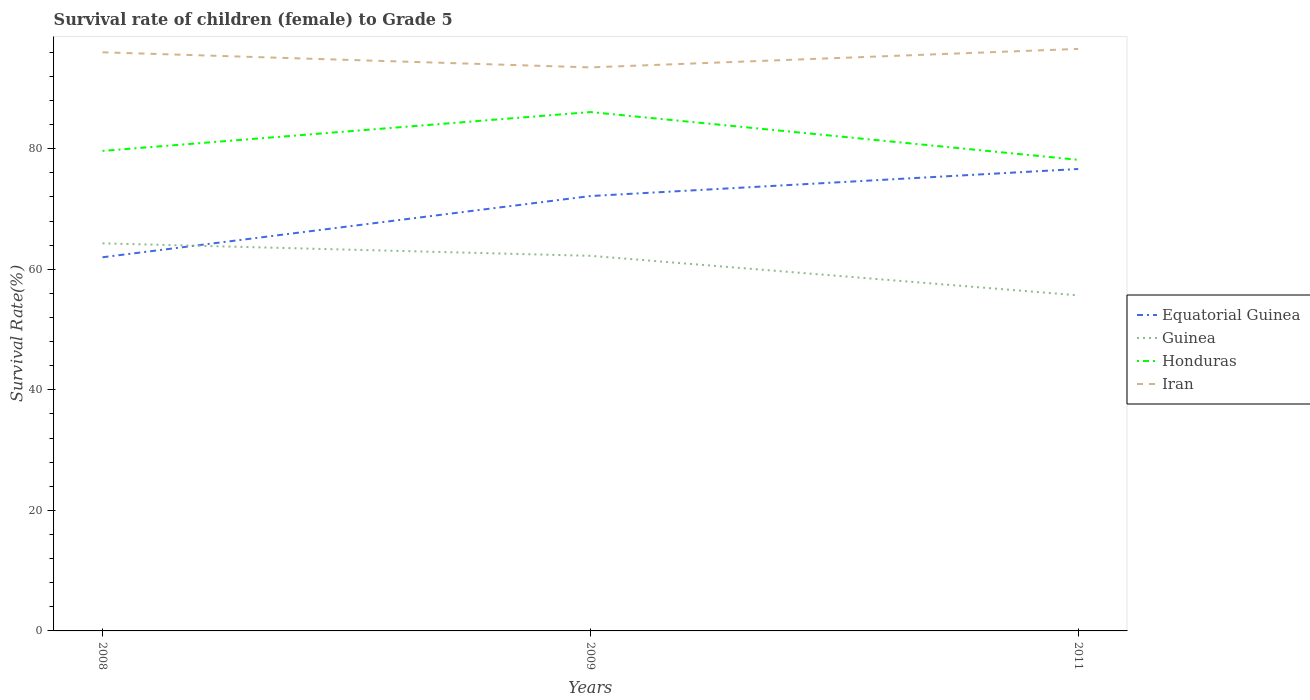Does the line corresponding to Iran intersect with the line corresponding to Honduras?
Ensure brevity in your answer.  No. Is the number of lines equal to the number of legend labels?
Your answer should be very brief. Yes. Across all years, what is the maximum survival rate of female children to grade 5 in Iran?
Offer a terse response. 93.49. What is the total survival rate of female children to grade 5 in Iran in the graph?
Your response must be concise. 2.5. What is the difference between the highest and the second highest survival rate of female children to grade 5 in Iran?
Offer a terse response. 3.07. What is the difference between the highest and the lowest survival rate of female children to grade 5 in Guinea?
Provide a succinct answer. 2. Is the survival rate of female children to grade 5 in Honduras strictly greater than the survival rate of female children to grade 5 in Equatorial Guinea over the years?
Your answer should be compact. No. How many lines are there?
Your answer should be very brief. 4. Does the graph contain grids?
Give a very brief answer. No. Where does the legend appear in the graph?
Offer a very short reply. Center right. What is the title of the graph?
Keep it short and to the point. Survival rate of children (female) to Grade 5. Does "Ireland" appear as one of the legend labels in the graph?
Your answer should be very brief. No. What is the label or title of the X-axis?
Your answer should be compact. Years. What is the label or title of the Y-axis?
Offer a very short reply. Survival Rate(%). What is the Survival Rate(%) in Equatorial Guinea in 2008?
Your response must be concise. 61.99. What is the Survival Rate(%) of Guinea in 2008?
Offer a terse response. 64.3. What is the Survival Rate(%) of Honduras in 2008?
Keep it short and to the point. 79.63. What is the Survival Rate(%) of Iran in 2008?
Give a very brief answer. 95.99. What is the Survival Rate(%) of Equatorial Guinea in 2009?
Make the answer very short. 72.14. What is the Survival Rate(%) in Guinea in 2009?
Provide a short and direct response. 62.23. What is the Survival Rate(%) of Honduras in 2009?
Provide a short and direct response. 86.08. What is the Survival Rate(%) of Iran in 2009?
Offer a terse response. 93.49. What is the Survival Rate(%) of Equatorial Guinea in 2011?
Offer a very short reply. 76.63. What is the Survival Rate(%) in Guinea in 2011?
Your answer should be very brief. 55.67. What is the Survival Rate(%) of Honduras in 2011?
Your response must be concise. 78.15. What is the Survival Rate(%) in Iran in 2011?
Make the answer very short. 96.55. Across all years, what is the maximum Survival Rate(%) in Equatorial Guinea?
Give a very brief answer. 76.63. Across all years, what is the maximum Survival Rate(%) in Guinea?
Ensure brevity in your answer.  64.3. Across all years, what is the maximum Survival Rate(%) of Honduras?
Your answer should be very brief. 86.08. Across all years, what is the maximum Survival Rate(%) of Iran?
Give a very brief answer. 96.55. Across all years, what is the minimum Survival Rate(%) of Equatorial Guinea?
Keep it short and to the point. 61.99. Across all years, what is the minimum Survival Rate(%) of Guinea?
Your answer should be very brief. 55.67. Across all years, what is the minimum Survival Rate(%) in Honduras?
Offer a terse response. 78.15. Across all years, what is the minimum Survival Rate(%) in Iran?
Provide a succinct answer. 93.49. What is the total Survival Rate(%) in Equatorial Guinea in the graph?
Offer a terse response. 210.76. What is the total Survival Rate(%) of Guinea in the graph?
Your answer should be compact. 182.2. What is the total Survival Rate(%) in Honduras in the graph?
Keep it short and to the point. 243.86. What is the total Survival Rate(%) in Iran in the graph?
Provide a short and direct response. 286.03. What is the difference between the Survival Rate(%) of Equatorial Guinea in 2008 and that in 2009?
Provide a short and direct response. -10.16. What is the difference between the Survival Rate(%) in Guinea in 2008 and that in 2009?
Your response must be concise. 2.07. What is the difference between the Survival Rate(%) in Honduras in 2008 and that in 2009?
Provide a succinct answer. -6.44. What is the difference between the Survival Rate(%) of Iran in 2008 and that in 2009?
Your response must be concise. 2.5. What is the difference between the Survival Rate(%) in Equatorial Guinea in 2008 and that in 2011?
Ensure brevity in your answer.  -14.65. What is the difference between the Survival Rate(%) of Guinea in 2008 and that in 2011?
Ensure brevity in your answer.  8.62. What is the difference between the Survival Rate(%) of Honduras in 2008 and that in 2011?
Offer a terse response. 1.48. What is the difference between the Survival Rate(%) of Iran in 2008 and that in 2011?
Offer a terse response. -0.56. What is the difference between the Survival Rate(%) in Equatorial Guinea in 2009 and that in 2011?
Ensure brevity in your answer.  -4.49. What is the difference between the Survival Rate(%) of Guinea in 2009 and that in 2011?
Your answer should be very brief. 6.56. What is the difference between the Survival Rate(%) of Honduras in 2009 and that in 2011?
Give a very brief answer. 7.93. What is the difference between the Survival Rate(%) in Iran in 2009 and that in 2011?
Offer a terse response. -3.07. What is the difference between the Survival Rate(%) in Equatorial Guinea in 2008 and the Survival Rate(%) in Guinea in 2009?
Your response must be concise. -0.24. What is the difference between the Survival Rate(%) of Equatorial Guinea in 2008 and the Survival Rate(%) of Honduras in 2009?
Make the answer very short. -24.09. What is the difference between the Survival Rate(%) in Equatorial Guinea in 2008 and the Survival Rate(%) in Iran in 2009?
Offer a very short reply. -31.5. What is the difference between the Survival Rate(%) in Guinea in 2008 and the Survival Rate(%) in Honduras in 2009?
Your answer should be very brief. -21.78. What is the difference between the Survival Rate(%) of Guinea in 2008 and the Survival Rate(%) of Iran in 2009?
Offer a very short reply. -29.19. What is the difference between the Survival Rate(%) of Honduras in 2008 and the Survival Rate(%) of Iran in 2009?
Make the answer very short. -13.85. What is the difference between the Survival Rate(%) of Equatorial Guinea in 2008 and the Survival Rate(%) of Guinea in 2011?
Keep it short and to the point. 6.31. What is the difference between the Survival Rate(%) of Equatorial Guinea in 2008 and the Survival Rate(%) of Honduras in 2011?
Give a very brief answer. -16.16. What is the difference between the Survival Rate(%) in Equatorial Guinea in 2008 and the Survival Rate(%) in Iran in 2011?
Keep it short and to the point. -34.57. What is the difference between the Survival Rate(%) of Guinea in 2008 and the Survival Rate(%) of Honduras in 2011?
Offer a very short reply. -13.85. What is the difference between the Survival Rate(%) of Guinea in 2008 and the Survival Rate(%) of Iran in 2011?
Provide a succinct answer. -32.26. What is the difference between the Survival Rate(%) in Honduras in 2008 and the Survival Rate(%) in Iran in 2011?
Make the answer very short. -16.92. What is the difference between the Survival Rate(%) of Equatorial Guinea in 2009 and the Survival Rate(%) of Guinea in 2011?
Give a very brief answer. 16.47. What is the difference between the Survival Rate(%) of Equatorial Guinea in 2009 and the Survival Rate(%) of Honduras in 2011?
Give a very brief answer. -6.01. What is the difference between the Survival Rate(%) in Equatorial Guinea in 2009 and the Survival Rate(%) in Iran in 2011?
Your answer should be compact. -24.41. What is the difference between the Survival Rate(%) in Guinea in 2009 and the Survival Rate(%) in Honduras in 2011?
Make the answer very short. -15.92. What is the difference between the Survival Rate(%) in Guinea in 2009 and the Survival Rate(%) in Iran in 2011?
Offer a terse response. -34.32. What is the difference between the Survival Rate(%) in Honduras in 2009 and the Survival Rate(%) in Iran in 2011?
Offer a very short reply. -10.48. What is the average Survival Rate(%) of Equatorial Guinea per year?
Your response must be concise. 70.25. What is the average Survival Rate(%) of Guinea per year?
Give a very brief answer. 60.73. What is the average Survival Rate(%) in Honduras per year?
Give a very brief answer. 81.29. What is the average Survival Rate(%) in Iran per year?
Offer a terse response. 95.34. In the year 2008, what is the difference between the Survival Rate(%) in Equatorial Guinea and Survival Rate(%) in Guinea?
Your answer should be very brief. -2.31. In the year 2008, what is the difference between the Survival Rate(%) in Equatorial Guinea and Survival Rate(%) in Honduras?
Your response must be concise. -17.65. In the year 2008, what is the difference between the Survival Rate(%) of Equatorial Guinea and Survival Rate(%) of Iran?
Your response must be concise. -34. In the year 2008, what is the difference between the Survival Rate(%) in Guinea and Survival Rate(%) in Honduras?
Ensure brevity in your answer.  -15.34. In the year 2008, what is the difference between the Survival Rate(%) in Guinea and Survival Rate(%) in Iran?
Your answer should be compact. -31.69. In the year 2008, what is the difference between the Survival Rate(%) in Honduras and Survival Rate(%) in Iran?
Give a very brief answer. -16.36. In the year 2009, what is the difference between the Survival Rate(%) of Equatorial Guinea and Survival Rate(%) of Guinea?
Your answer should be very brief. 9.91. In the year 2009, what is the difference between the Survival Rate(%) of Equatorial Guinea and Survival Rate(%) of Honduras?
Give a very brief answer. -13.93. In the year 2009, what is the difference between the Survival Rate(%) in Equatorial Guinea and Survival Rate(%) in Iran?
Keep it short and to the point. -21.34. In the year 2009, what is the difference between the Survival Rate(%) in Guinea and Survival Rate(%) in Honduras?
Give a very brief answer. -23.85. In the year 2009, what is the difference between the Survival Rate(%) in Guinea and Survival Rate(%) in Iran?
Your answer should be very brief. -31.26. In the year 2009, what is the difference between the Survival Rate(%) of Honduras and Survival Rate(%) of Iran?
Your answer should be compact. -7.41. In the year 2011, what is the difference between the Survival Rate(%) of Equatorial Guinea and Survival Rate(%) of Guinea?
Make the answer very short. 20.96. In the year 2011, what is the difference between the Survival Rate(%) of Equatorial Guinea and Survival Rate(%) of Honduras?
Make the answer very short. -1.52. In the year 2011, what is the difference between the Survival Rate(%) in Equatorial Guinea and Survival Rate(%) in Iran?
Offer a very short reply. -19.92. In the year 2011, what is the difference between the Survival Rate(%) in Guinea and Survival Rate(%) in Honduras?
Offer a terse response. -22.48. In the year 2011, what is the difference between the Survival Rate(%) of Guinea and Survival Rate(%) of Iran?
Give a very brief answer. -40.88. In the year 2011, what is the difference between the Survival Rate(%) in Honduras and Survival Rate(%) in Iran?
Offer a terse response. -18.4. What is the ratio of the Survival Rate(%) of Equatorial Guinea in 2008 to that in 2009?
Give a very brief answer. 0.86. What is the ratio of the Survival Rate(%) of Guinea in 2008 to that in 2009?
Keep it short and to the point. 1.03. What is the ratio of the Survival Rate(%) of Honduras in 2008 to that in 2009?
Make the answer very short. 0.93. What is the ratio of the Survival Rate(%) of Iran in 2008 to that in 2009?
Make the answer very short. 1.03. What is the ratio of the Survival Rate(%) in Equatorial Guinea in 2008 to that in 2011?
Your response must be concise. 0.81. What is the ratio of the Survival Rate(%) of Guinea in 2008 to that in 2011?
Offer a terse response. 1.15. What is the ratio of the Survival Rate(%) in Honduras in 2008 to that in 2011?
Provide a succinct answer. 1.02. What is the ratio of the Survival Rate(%) in Iran in 2008 to that in 2011?
Provide a succinct answer. 0.99. What is the ratio of the Survival Rate(%) of Equatorial Guinea in 2009 to that in 2011?
Ensure brevity in your answer.  0.94. What is the ratio of the Survival Rate(%) of Guinea in 2009 to that in 2011?
Your response must be concise. 1.12. What is the ratio of the Survival Rate(%) of Honduras in 2009 to that in 2011?
Your answer should be compact. 1.1. What is the ratio of the Survival Rate(%) of Iran in 2009 to that in 2011?
Ensure brevity in your answer.  0.97. What is the difference between the highest and the second highest Survival Rate(%) in Equatorial Guinea?
Provide a short and direct response. 4.49. What is the difference between the highest and the second highest Survival Rate(%) in Guinea?
Offer a terse response. 2.07. What is the difference between the highest and the second highest Survival Rate(%) in Honduras?
Offer a very short reply. 6.44. What is the difference between the highest and the second highest Survival Rate(%) of Iran?
Provide a short and direct response. 0.56. What is the difference between the highest and the lowest Survival Rate(%) of Equatorial Guinea?
Offer a very short reply. 14.65. What is the difference between the highest and the lowest Survival Rate(%) of Guinea?
Provide a succinct answer. 8.62. What is the difference between the highest and the lowest Survival Rate(%) of Honduras?
Make the answer very short. 7.93. What is the difference between the highest and the lowest Survival Rate(%) of Iran?
Keep it short and to the point. 3.07. 